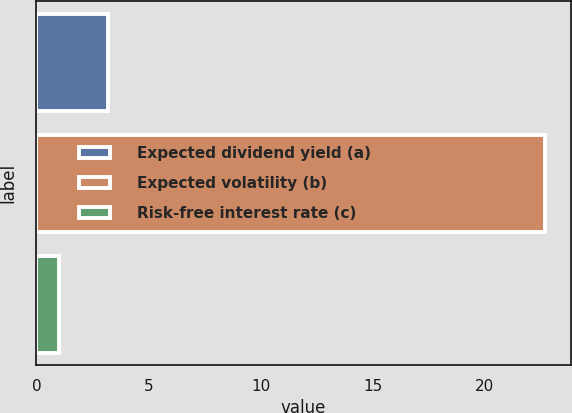Convert chart. <chart><loc_0><loc_0><loc_500><loc_500><bar_chart><fcel>Expected dividend yield (a)<fcel>Expected volatility (b)<fcel>Risk-free interest rate (c)<nl><fcel>3.18<fcel>22.71<fcel>1.01<nl></chart> 